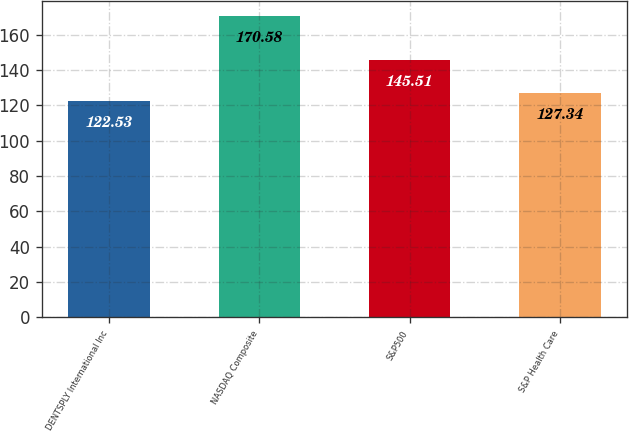Convert chart to OTSL. <chart><loc_0><loc_0><loc_500><loc_500><bar_chart><fcel>DENTSPLY International Inc<fcel>NASDAQ Composite<fcel>S&P500<fcel>S&P Health Care<nl><fcel>122.53<fcel>170.58<fcel>145.51<fcel>127.34<nl></chart> 